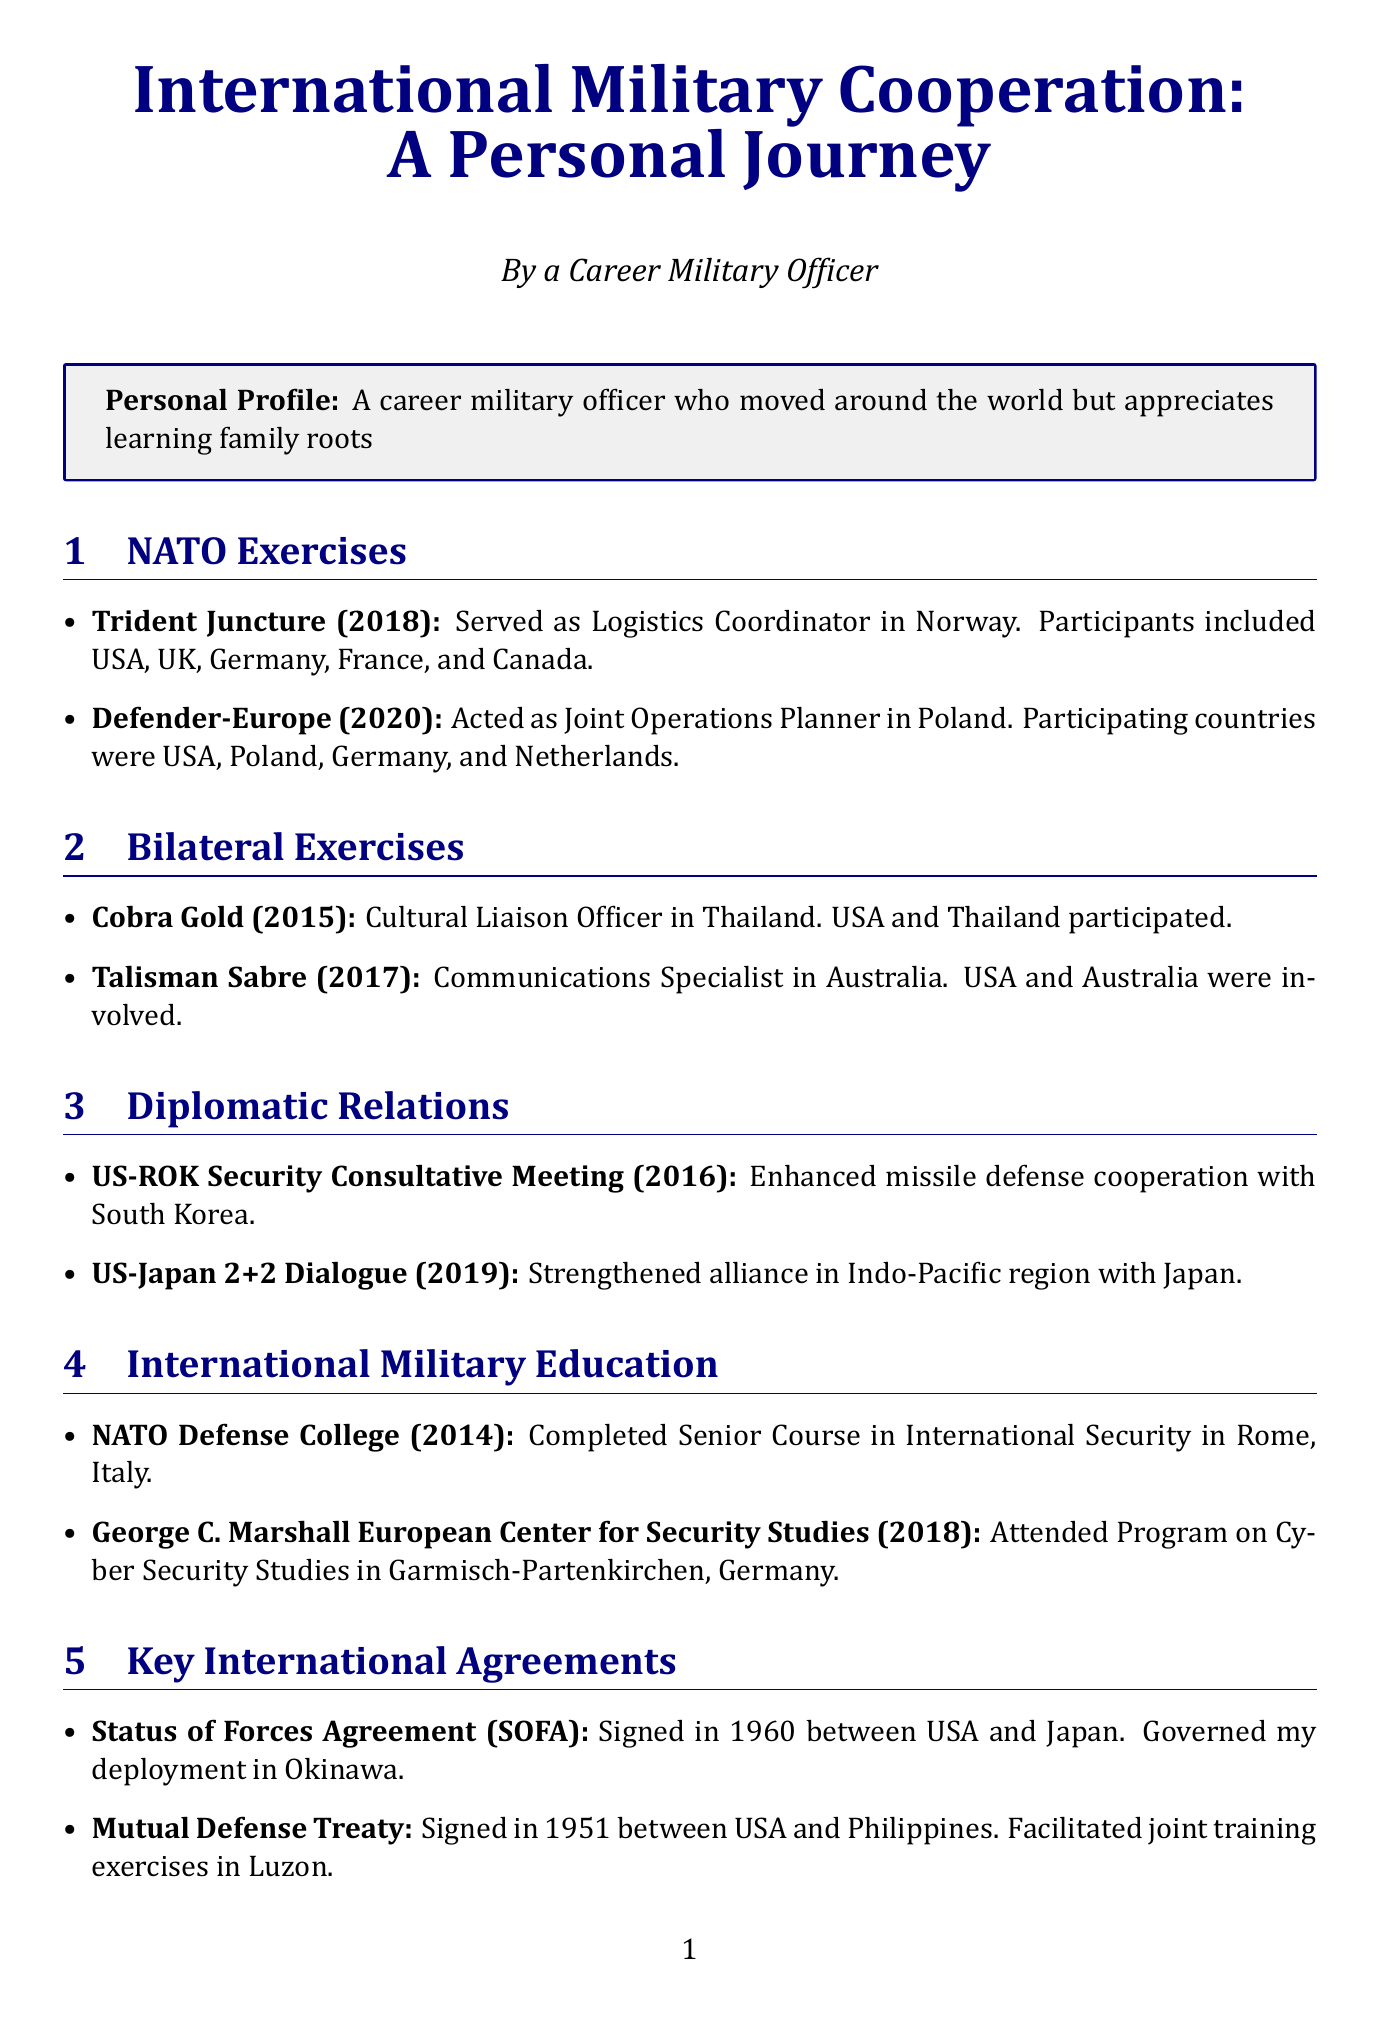What year was the Trident Juncture exercise held? The document states that Trident Juncture was held in Norway in 2018.
Answer: 2018 Which role did you serve in during the Defender-Europe exercise? The document mentions that the personal role in Defender-Europe (2020) was as Joint Operations Planner.
Answer: Joint Operations Planner What is the outcome of the US-ROK Security Consultative Meeting in 2016? The document indicates that the outcome was enhanced missile defense cooperation with South Korea.
Answer: Enhanced missile defense cooperation How many years after the Mutual Defense Treaty was signed did it facilitate joint training exercises in Luzon? The document states the Mutual Defense Treaty was signed in 1951, and the document does not specify any year for joint exercises, making it a reasoning question requiring inference of duration.
Answer: Not specified What is the cultural impact of Jeong culture in South Korea on military cooperation? The document highlights that Jeong culture emphasizes strong bonds and loyalty in joint operations.
Answer: Strong bonds and loyalty Which technological project involved coordination of logistics for multinational pilot training? The document mentions that the F-35 Joint Strike Fighter project involved coordination of logistics for multinational pilot training.
Answer: F-35 Joint Strike Fighter What were the two primary challenges faced during joint exercises? The document lists language barriers and differing Rules of Engagement as the primary challenges.
Answer: Language barriers, differing ROE In which city and country did you complete the Senior Course in International Security? The document states that the course was completed at NATO Defense College in Rome, Italy.
Answer: Rome, Italy What type of insights does the document provide regarding cultural adaptations? The document provides cultural insights that include customs and their impact on military cooperation.
Answer: Cultural insights 